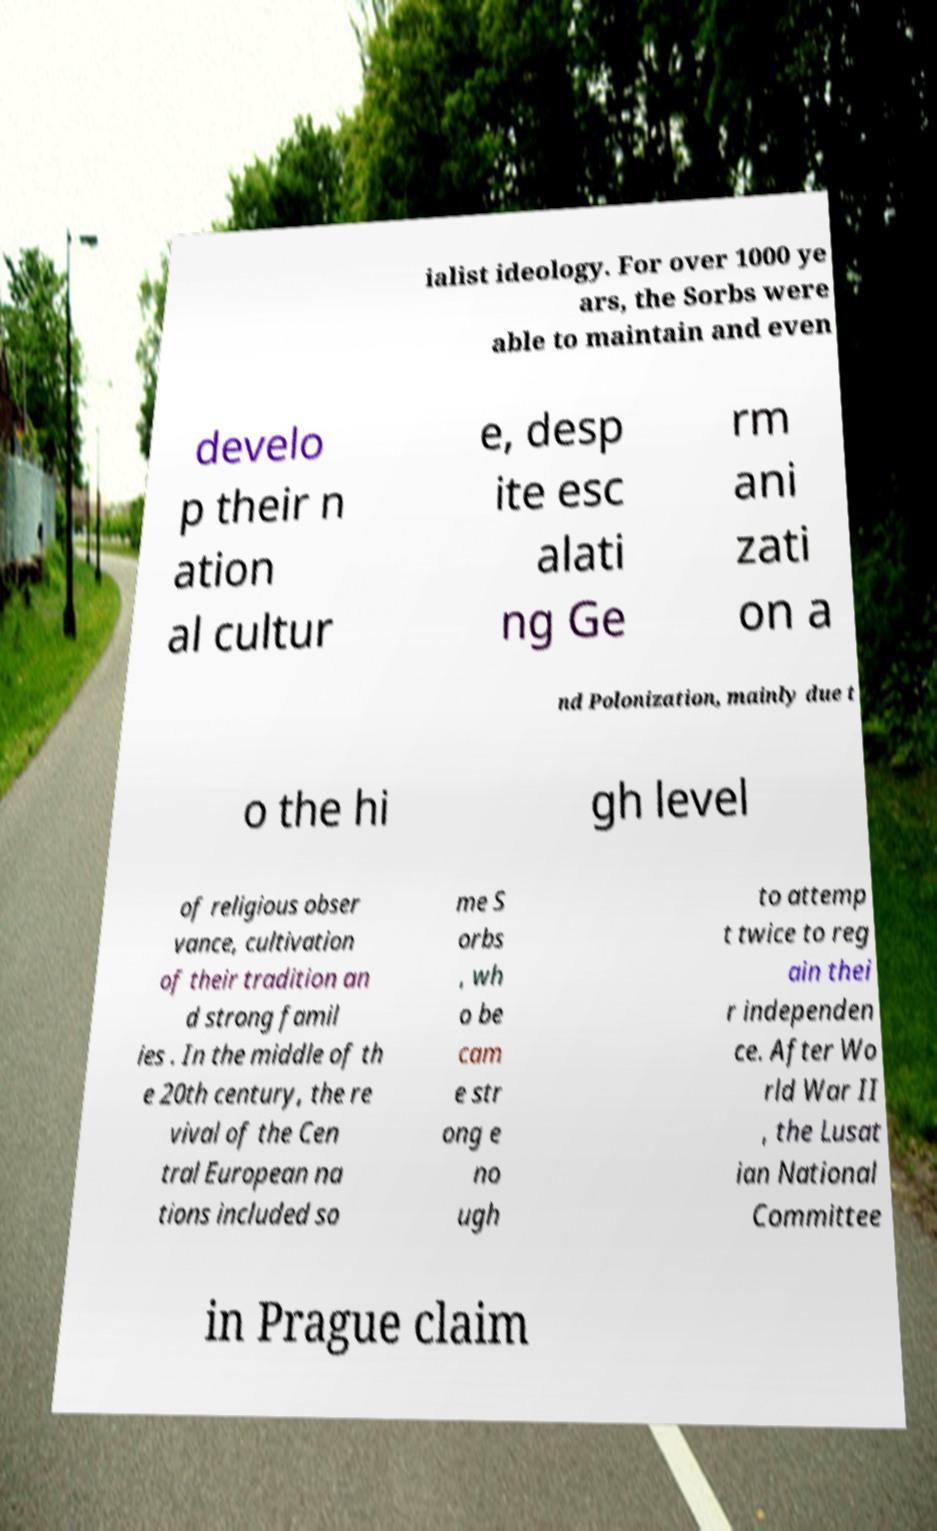Could you extract and type out the text from this image? ialist ideology. For over 1000 ye ars, the Sorbs were able to maintain and even develo p their n ation al cultur e, desp ite esc alati ng Ge rm ani zati on a nd Polonization, mainly due t o the hi gh level of religious obser vance, cultivation of their tradition an d strong famil ies . In the middle of th e 20th century, the re vival of the Cen tral European na tions included so me S orbs , wh o be cam e str ong e no ugh to attemp t twice to reg ain thei r independen ce. After Wo rld War II , the Lusat ian National Committee in Prague claim 